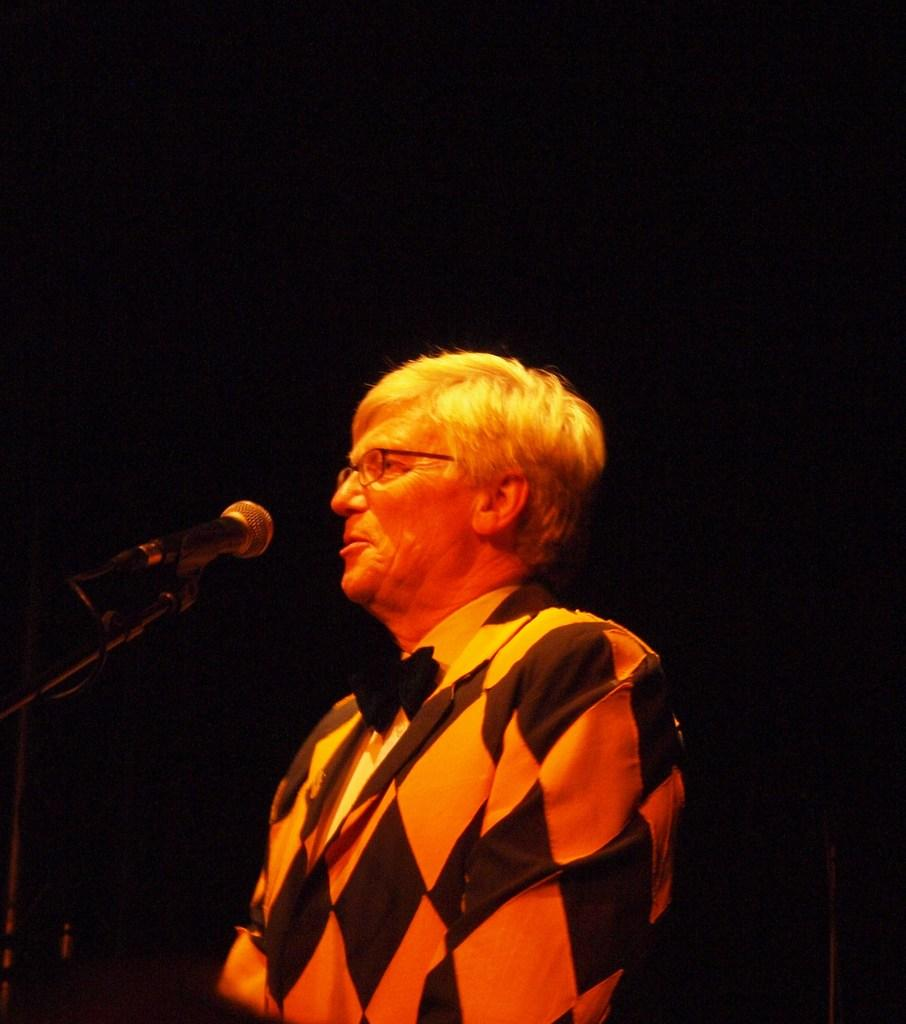What is the main subject of the image? There is a person standing in the image. What is the person doing in the image? The person is talking into a microphone. Can you describe the background of the image? The background of the image is dark. What type of playground equipment can be seen in the image? There is no playground equipment present in the image. What discovery was made on the paper in the image? There is no paper or discovery mentioned in the image. 